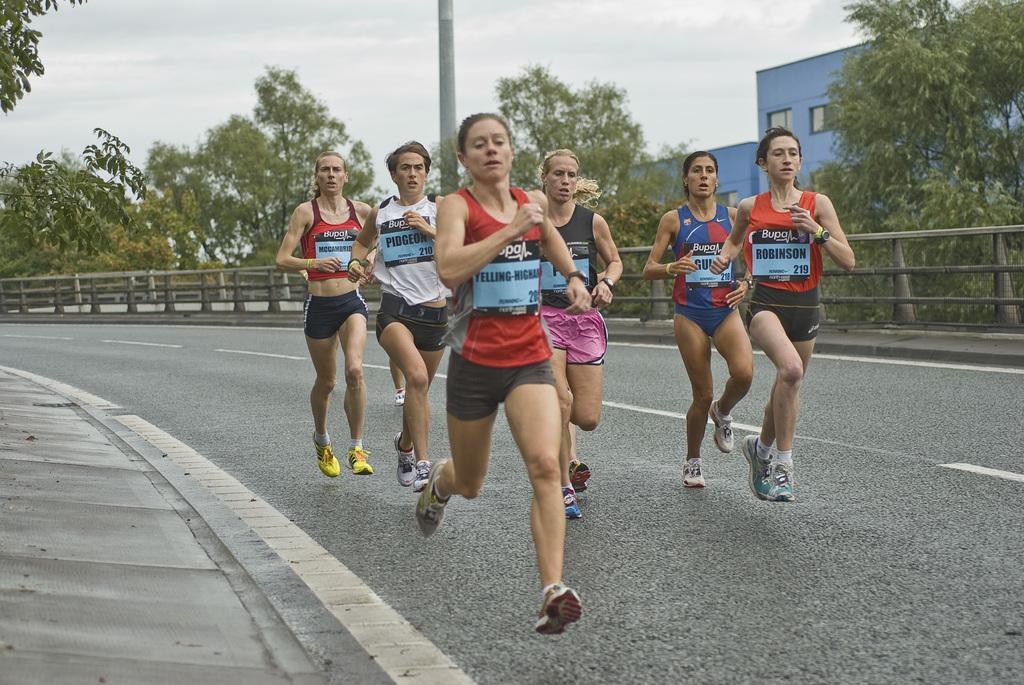Describe this image in one or two sentences. There is a group of persons running on the road as we can see in the middle of this image. We can see a fence and trees in the background. There is a building on the right side of this image. The sky is at the top of this image. 